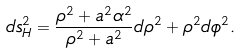<formula> <loc_0><loc_0><loc_500><loc_500>d s _ { H } ^ { 2 } = \frac { \rho ^ { 2 } + a ^ { 2 } \alpha ^ { 2 } } { \rho ^ { 2 } + a ^ { 2 } } d \rho ^ { 2 } + \rho ^ { 2 } d \phi ^ { 2 } .</formula> 